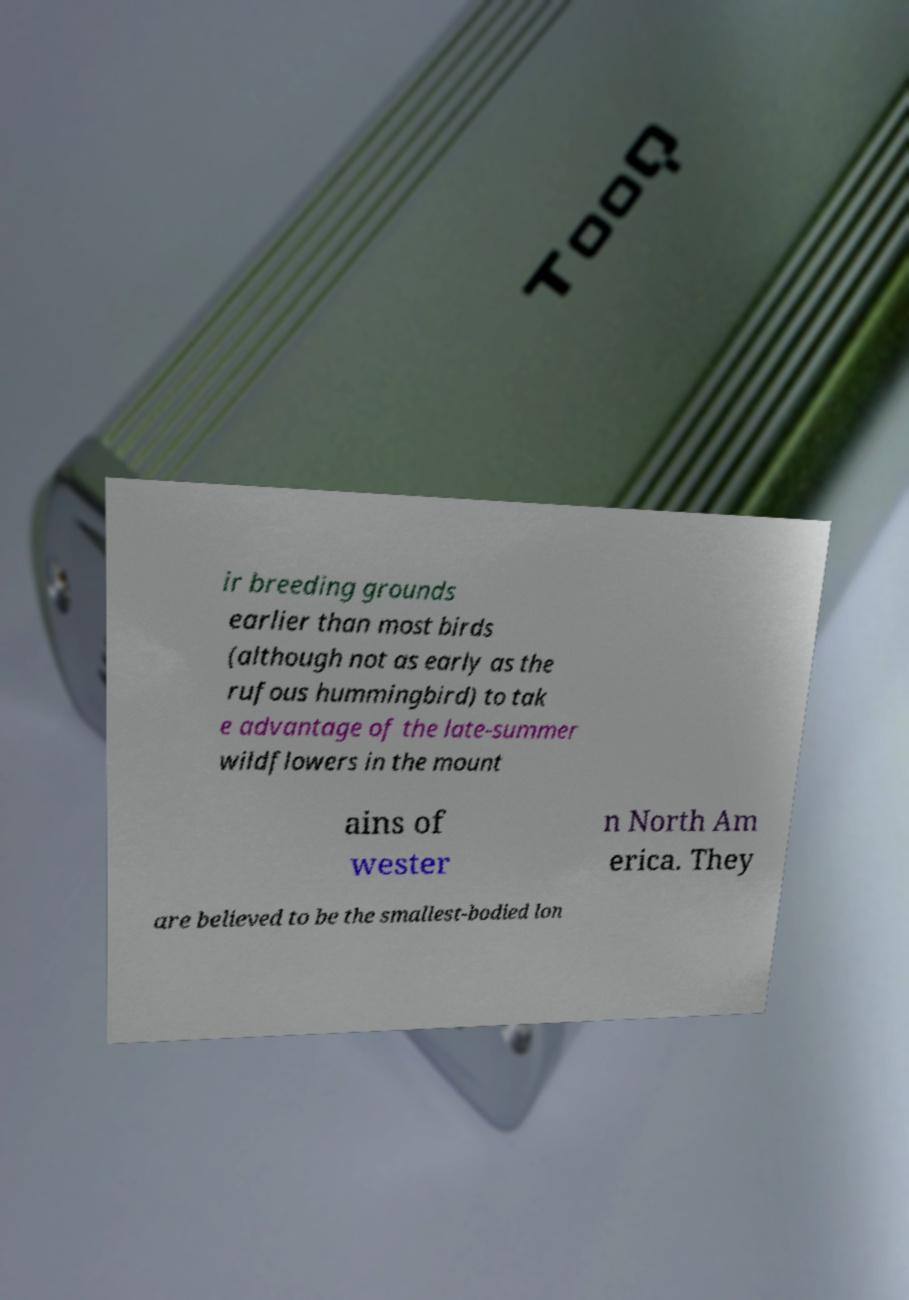Can you read and provide the text displayed in the image?This photo seems to have some interesting text. Can you extract and type it out for me? ir breeding grounds earlier than most birds (although not as early as the rufous hummingbird) to tak e advantage of the late-summer wildflowers in the mount ains of wester n North Am erica. They are believed to be the smallest-bodied lon 